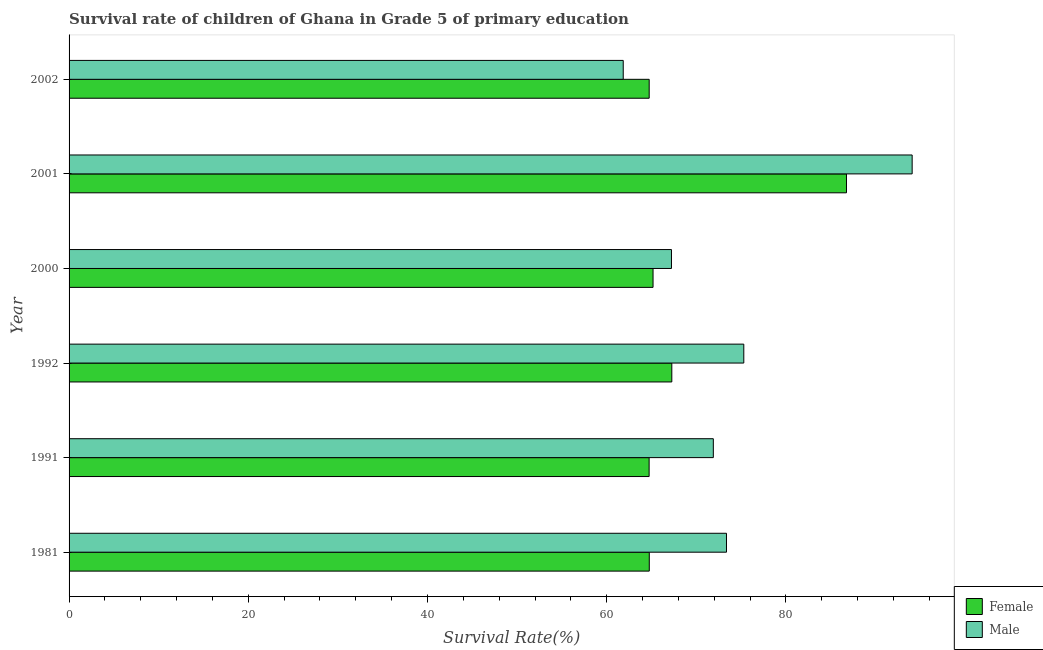Are the number of bars per tick equal to the number of legend labels?
Give a very brief answer. Yes. Are the number of bars on each tick of the Y-axis equal?
Your answer should be very brief. Yes. How many bars are there on the 2nd tick from the top?
Keep it short and to the point. 2. How many bars are there on the 1st tick from the bottom?
Offer a very short reply. 2. What is the label of the 6th group of bars from the top?
Provide a short and direct response. 1981. In how many cases, is the number of bars for a given year not equal to the number of legend labels?
Give a very brief answer. 0. What is the survival rate of female students in primary education in 2000?
Keep it short and to the point. 65.17. Across all years, what is the maximum survival rate of female students in primary education?
Provide a succinct answer. 86.76. Across all years, what is the minimum survival rate of male students in primary education?
Make the answer very short. 61.85. In which year was the survival rate of female students in primary education maximum?
Provide a succinct answer. 2001. In which year was the survival rate of male students in primary education minimum?
Provide a succinct answer. 2002. What is the total survival rate of female students in primary education in the graph?
Make the answer very short. 413.44. What is the difference between the survival rate of female students in primary education in 1981 and that in 2002?
Your answer should be very brief. 0.01. What is the difference between the survival rate of male students in primary education in 2002 and the survival rate of female students in primary education in 2001?
Offer a terse response. -24.92. What is the average survival rate of male students in primary education per year?
Offer a very short reply. 73.96. In the year 2000, what is the difference between the survival rate of female students in primary education and survival rate of male students in primary education?
Offer a terse response. -2.06. In how many years, is the survival rate of male students in primary education greater than 40 %?
Provide a succinct answer. 6. What is the ratio of the survival rate of male students in primary education in 1991 to that in 1992?
Give a very brief answer. 0.95. What is the difference between the highest and the second highest survival rate of female students in primary education?
Ensure brevity in your answer.  19.49. What is the difference between the highest and the lowest survival rate of male students in primary education?
Offer a terse response. 32.24. In how many years, is the survival rate of male students in primary education greater than the average survival rate of male students in primary education taken over all years?
Give a very brief answer. 2. Is the sum of the survival rate of male students in primary education in 1981 and 2002 greater than the maximum survival rate of female students in primary education across all years?
Offer a terse response. Yes. How many years are there in the graph?
Provide a short and direct response. 6. What is the difference between two consecutive major ticks on the X-axis?
Give a very brief answer. 20. Does the graph contain any zero values?
Your answer should be compact. No. Where does the legend appear in the graph?
Give a very brief answer. Bottom right. How are the legend labels stacked?
Your answer should be compact. Vertical. What is the title of the graph?
Give a very brief answer. Survival rate of children of Ghana in Grade 5 of primary education. What is the label or title of the X-axis?
Your answer should be compact. Survival Rate(%). What is the label or title of the Y-axis?
Make the answer very short. Year. What is the Survival Rate(%) in Female in 1981?
Give a very brief answer. 64.75. What is the Survival Rate(%) in Male in 1981?
Make the answer very short. 73.37. What is the Survival Rate(%) in Female in 1991?
Make the answer very short. 64.74. What is the Survival Rate(%) in Male in 1991?
Your answer should be compact. 71.9. What is the Survival Rate(%) of Female in 1992?
Provide a succinct answer. 67.27. What is the Survival Rate(%) in Male in 1992?
Your response must be concise. 75.3. What is the Survival Rate(%) of Female in 2000?
Provide a short and direct response. 65.17. What is the Survival Rate(%) of Male in 2000?
Your answer should be compact. 67.23. What is the Survival Rate(%) in Female in 2001?
Make the answer very short. 86.76. What is the Survival Rate(%) of Male in 2001?
Keep it short and to the point. 94.09. What is the Survival Rate(%) in Female in 2002?
Make the answer very short. 64.74. What is the Survival Rate(%) of Male in 2002?
Offer a terse response. 61.85. Across all years, what is the maximum Survival Rate(%) in Female?
Keep it short and to the point. 86.76. Across all years, what is the maximum Survival Rate(%) in Male?
Your response must be concise. 94.09. Across all years, what is the minimum Survival Rate(%) in Female?
Give a very brief answer. 64.74. Across all years, what is the minimum Survival Rate(%) of Male?
Give a very brief answer. 61.85. What is the total Survival Rate(%) in Female in the graph?
Ensure brevity in your answer.  413.44. What is the total Survival Rate(%) in Male in the graph?
Provide a succinct answer. 443.74. What is the difference between the Survival Rate(%) of Female in 1981 and that in 1991?
Your answer should be compact. 0.02. What is the difference between the Survival Rate(%) of Male in 1981 and that in 1991?
Offer a very short reply. 1.47. What is the difference between the Survival Rate(%) in Female in 1981 and that in 1992?
Offer a very short reply. -2.51. What is the difference between the Survival Rate(%) of Male in 1981 and that in 1992?
Provide a succinct answer. -1.93. What is the difference between the Survival Rate(%) in Female in 1981 and that in 2000?
Offer a terse response. -0.42. What is the difference between the Survival Rate(%) in Male in 1981 and that in 2000?
Your answer should be very brief. 6.14. What is the difference between the Survival Rate(%) of Female in 1981 and that in 2001?
Provide a short and direct response. -22.01. What is the difference between the Survival Rate(%) of Male in 1981 and that in 2001?
Keep it short and to the point. -20.72. What is the difference between the Survival Rate(%) of Female in 1981 and that in 2002?
Give a very brief answer. 0.01. What is the difference between the Survival Rate(%) in Male in 1981 and that in 2002?
Keep it short and to the point. 11.52. What is the difference between the Survival Rate(%) in Female in 1991 and that in 1992?
Your answer should be compact. -2.53. What is the difference between the Survival Rate(%) in Male in 1991 and that in 1992?
Ensure brevity in your answer.  -3.4. What is the difference between the Survival Rate(%) of Female in 1991 and that in 2000?
Give a very brief answer. -0.44. What is the difference between the Survival Rate(%) of Male in 1991 and that in 2000?
Your answer should be very brief. 4.67. What is the difference between the Survival Rate(%) of Female in 1991 and that in 2001?
Make the answer very short. -22.03. What is the difference between the Survival Rate(%) in Male in 1991 and that in 2001?
Offer a terse response. -22.19. What is the difference between the Survival Rate(%) of Female in 1991 and that in 2002?
Make the answer very short. -0.01. What is the difference between the Survival Rate(%) of Male in 1991 and that in 2002?
Offer a terse response. 10.05. What is the difference between the Survival Rate(%) in Female in 1992 and that in 2000?
Offer a terse response. 2.09. What is the difference between the Survival Rate(%) of Male in 1992 and that in 2000?
Make the answer very short. 8.07. What is the difference between the Survival Rate(%) in Female in 1992 and that in 2001?
Offer a very short reply. -19.49. What is the difference between the Survival Rate(%) in Male in 1992 and that in 2001?
Ensure brevity in your answer.  -18.79. What is the difference between the Survival Rate(%) of Female in 1992 and that in 2002?
Your answer should be very brief. 2.53. What is the difference between the Survival Rate(%) of Male in 1992 and that in 2002?
Your response must be concise. 13.45. What is the difference between the Survival Rate(%) in Female in 2000 and that in 2001?
Offer a terse response. -21.59. What is the difference between the Survival Rate(%) of Male in 2000 and that in 2001?
Provide a succinct answer. -26.86. What is the difference between the Survival Rate(%) in Female in 2000 and that in 2002?
Provide a short and direct response. 0.43. What is the difference between the Survival Rate(%) of Male in 2000 and that in 2002?
Offer a terse response. 5.38. What is the difference between the Survival Rate(%) in Female in 2001 and that in 2002?
Offer a very short reply. 22.02. What is the difference between the Survival Rate(%) in Male in 2001 and that in 2002?
Ensure brevity in your answer.  32.24. What is the difference between the Survival Rate(%) of Female in 1981 and the Survival Rate(%) of Male in 1991?
Give a very brief answer. -7.15. What is the difference between the Survival Rate(%) of Female in 1981 and the Survival Rate(%) of Male in 1992?
Keep it short and to the point. -10.55. What is the difference between the Survival Rate(%) of Female in 1981 and the Survival Rate(%) of Male in 2000?
Keep it short and to the point. -2.48. What is the difference between the Survival Rate(%) in Female in 1981 and the Survival Rate(%) in Male in 2001?
Offer a very short reply. -29.34. What is the difference between the Survival Rate(%) in Female in 1981 and the Survival Rate(%) in Male in 2002?
Keep it short and to the point. 2.91. What is the difference between the Survival Rate(%) in Female in 1991 and the Survival Rate(%) in Male in 1992?
Give a very brief answer. -10.57. What is the difference between the Survival Rate(%) in Female in 1991 and the Survival Rate(%) in Male in 2000?
Provide a short and direct response. -2.49. What is the difference between the Survival Rate(%) in Female in 1991 and the Survival Rate(%) in Male in 2001?
Your answer should be very brief. -29.36. What is the difference between the Survival Rate(%) in Female in 1991 and the Survival Rate(%) in Male in 2002?
Ensure brevity in your answer.  2.89. What is the difference between the Survival Rate(%) in Female in 1992 and the Survival Rate(%) in Male in 2000?
Your answer should be very brief. 0.04. What is the difference between the Survival Rate(%) in Female in 1992 and the Survival Rate(%) in Male in 2001?
Your response must be concise. -26.82. What is the difference between the Survival Rate(%) of Female in 1992 and the Survival Rate(%) of Male in 2002?
Your answer should be very brief. 5.42. What is the difference between the Survival Rate(%) in Female in 2000 and the Survival Rate(%) in Male in 2001?
Make the answer very short. -28.92. What is the difference between the Survival Rate(%) in Female in 2000 and the Survival Rate(%) in Male in 2002?
Keep it short and to the point. 3.33. What is the difference between the Survival Rate(%) of Female in 2001 and the Survival Rate(%) of Male in 2002?
Provide a succinct answer. 24.92. What is the average Survival Rate(%) of Female per year?
Give a very brief answer. 68.91. What is the average Survival Rate(%) of Male per year?
Your response must be concise. 73.96. In the year 1981, what is the difference between the Survival Rate(%) in Female and Survival Rate(%) in Male?
Provide a short and direct response. -8.62. In the year 1991, what is the difference between the Survival Rate(%) in Female and Survival Rate(%) in Male?
Offer a very short reply. -7.17. In the year 1992, what is the difference between the Survival Rate(%) of Female and Survival Rate(%) of Male?
Offer a terse response. -8.03. In the year 2000, what is the difference between the Survival Rate(%) in Female and Survival Rate(%) in Male?
Your answer should be compact. -2.06. In the year 2001, what is the difference between the Survival Rate(%) of Female and Survival Rate(%) of Male?
Your response must be concise. -7.33. In the year 2002, what is the difference between the Survival Rate(%) in Female and Survival Rate(%) in Male?
Give a very brief answer. 2.9. What is the ratio of the Survival Rate(%) in Male in 1981 to that in 1991?
Ensure brevity in your answer.  1.02. What is the ratio of the Survival Rate(%) of Female in 1981 to that in 1992?
Keep it short and to the point. 0.96. What is the ratio of the Survival Rate(%) of Male in 1981 to that in 1992?
Give a very brief answer. 0.97. What is the ratio of the Survival Rate(%) in Male in 1981 to that in 2000?
Provide a short and direct response. 1.09. What is the ratio of the Survival Rate(%) of Female in 1981 to that in 2001?
Provide a succinct answer. 0.75. What is the ratio of the Survival Rate(%) in Male in 1981 to that in 2001?
Your answer should be compact. 0.78. What is the ratio of the Survival Rate(%) of Female in 1981 to that in 2002?
Ensure brevity in your answer.  1. What is the ratio of the Survival Rate(%) in Male in 1981 to that in 2002?
Your answer should be very brief. 1.19. What is the ratio of the Survival Rate(%) in Female in 1991 to that in 1992?
Offer a very short reply. 0.96. What is the ratio of the Survival Rate(%) in Male in 1991 to that in 1992?
Your answer should be very brief. 0.95. What is the ratio of the Survival Rate(%) in Female in 1991 to that in 2000?
Keep it short and to the point. 0.99. What is the ratio of the Survival Rate(%) of Male in 1991 to that in 2000?
Offer a very short reply. 1.07. What is the ratio of the Survival Rate(%) in Female in 1991 to that in 2001?
Provide a succinct answer. 0.75. What is the ratio of the Survival Rate(%) in Male in 1991 to that in 2001?
Provide a short and direct response. 0.76. What is the ratio of the Survival Rate(%) in Male in 1991 to that in 2002?
Make the answer very short. 1.16. What is the ratio of the Survival Rate(%) of Female in 1992 to that in 2000?
Ensure brevity in your answer.  1.03. What is the ratio of the Survival Rate(%) in Male in 1992 to that in 2000?
Keep it short and to the point. 1.12. What is the ratio of the Survival Rate(%) of Female in 1992 to that in 2001?
Provide a succinct answer. 0.78. What is the ratio of the Survival Rate(%) of Male in 1992 to that in 2001?
Provide a succinct answer. 0.8. What is the ratio of the Survival Rate(%) of Female in 1992 to that in 2002?
Offer a very short reply. 1.04. What is the ratio of the Survival Rate(%) in Male in 1992 to that in 2002?
Your answer should be very brief. 1.22. What is the ratio of the Survival Rate(%) in Female in 2000 to that in 2001?
Your response must be concise. 0.75. What is the ratio of the Survival Rate(%) of Male in 2000 to that in 2001?
Provide a succinct answer. 0.71. What is the ratio of the Survival Rate(%) in Female in 2000 to that in 2002?
Your answer should be compact. 1.01. What is the ratio of the Survival Rate(%) in Male in 2000 to that in 2002?
Offer a very short reply. 1.09. What is the ratio of the Survival Rate(%) of Female in 2001 to that in 2002?
Your response must be concise. 1.34. What is the ratio of the Survival Rate(%) of Male in 2001 to that in 2002?
Provide a short and direct response. 1.52. What is the difference between the highest and the second highest Survival Rate(%) of Female?
Provide a succinct answer. 19.49. What is the difference between the highest and the second highest Survival Rate(%) of Male?
Offer a very short reply. 18.79. What is the difference between the highest and the lowest Survival Rate(%) of Female?
Offer a very short reply. 22.03. What is the difference between the highest and the lowest Survival Rate(%) of Male?
Provide a succinct answer. 32.24. 